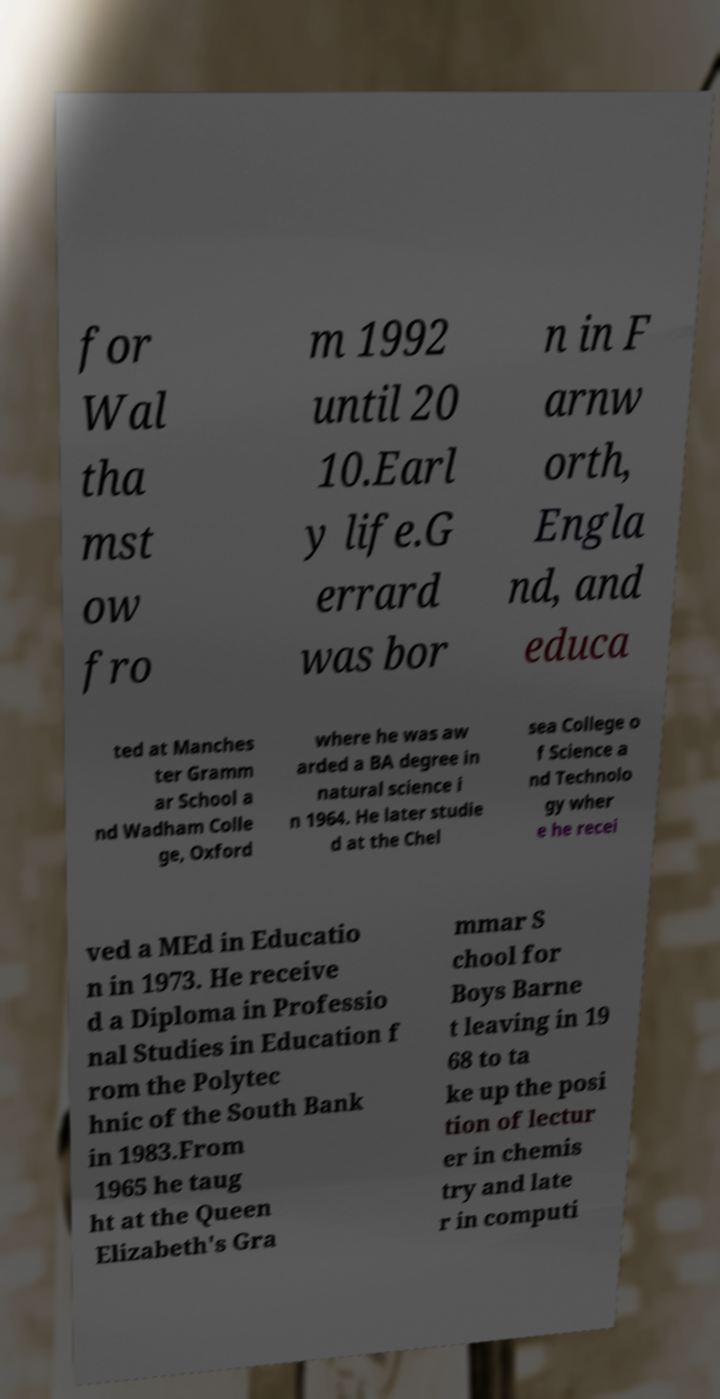What messages or text are displayed in this image? I need them in a readable, typed format. for Wal tha mst ow fro m 1992 until 20 10.Earl y life.G errard was bor n in F arnw orth, Engla nd, and educa ted at Manches ter Gramm ar School a nd Wadham Colle ge, Oxford where he was aw arded a BA degree in natural science i n 1964. He later studie d at the Chel sea College o f Science a nd Technolo gy wher e he recei ved a MEd in Educatio n in 1973. He receive d a Diploma in Professio nal Studies in Education f rom the Polytec hnic of the South Bank in 1983.From 1965 he taug ht at the Queen Elizabeth's Gra mmar S chool for Boys Barne t leaving in 19 68 to ta ke up the posi tion of lectur er in chemis try and late r in computi 